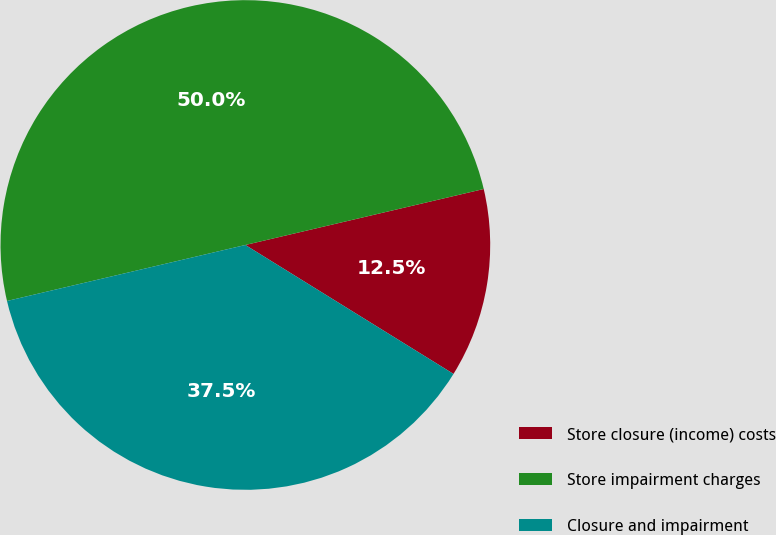Convert chart. <chart><loc_0><loc_0><loc_500><loc_500><pie_chart><fcel>Store closure (income) costs<fcel>Store impairment charges<fcel>Closure and impairment<nl><fcel>12.5%<fcel>50.0%<fcel>37.5%<nl></chart> 